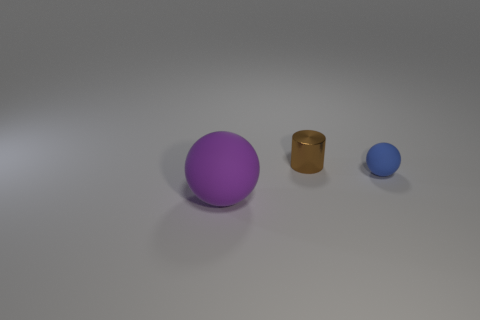What is the ball to the right of the object that is to the left of the tiny brown object made of?
Provide a succinct answer. Rubber. What number of other rubber objects are the same shape as the purple thing?
Your answer should be very brief. 1. There is a matte object that is to the left of the small object that is left of the tiny thing in front of the tiny brown metallic object; how big is it?
Keep it short and to the point. Large. What number of purple things are matte objects or large balls?
Provide a succinct answer. 1. Is the shape of the thing that is in front of the blue rubber ball the same as  the small matte thing?
Make the answer very short. Yes. Are there more small metal cylinders that are in front of the purple sphere than large cyan rubber cylinders?
Your answer should be very brief. No. How many green matte spheres are the same size as the metal cylinder?
Give a very brief answer. 0. What number of objects are balls or tiny things on the right side of the small brown cylinder?
Give a very brief answer. 2. The thing that is both on the right side of the purple ball and in front of the tiny brown cylinder is what color?
Offer a very short reply. Blue. Is the size of the brown cylinder the same as the purple thing?
Provide a short and direct response. No. 